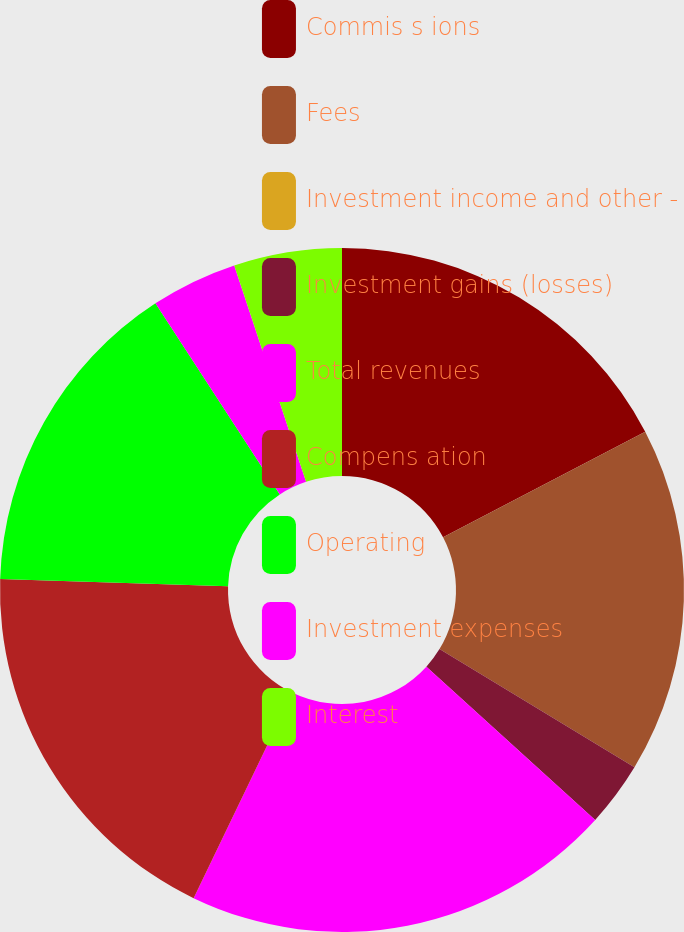Convert chart. <chart><loc_0><loc_0><loc_500><loc_500><pie_chart><fcel>Commis s ions<fcel>Fees<fcel>Investment income and other -<fcel>Investment gains (losses)<fcel>Total revenues<fcel>Compens ation<fcel>Operating<fcel>Investment expenses<fcel>Interest<nl><fcel>17.34%<fcel>16.32%<fcel>0.0%<fcel>3.06%<fcel>20.4%<fcel>18.36%<fcel>15.3%<fcel>4.08%<fcel>5.1%<nl></chart> 